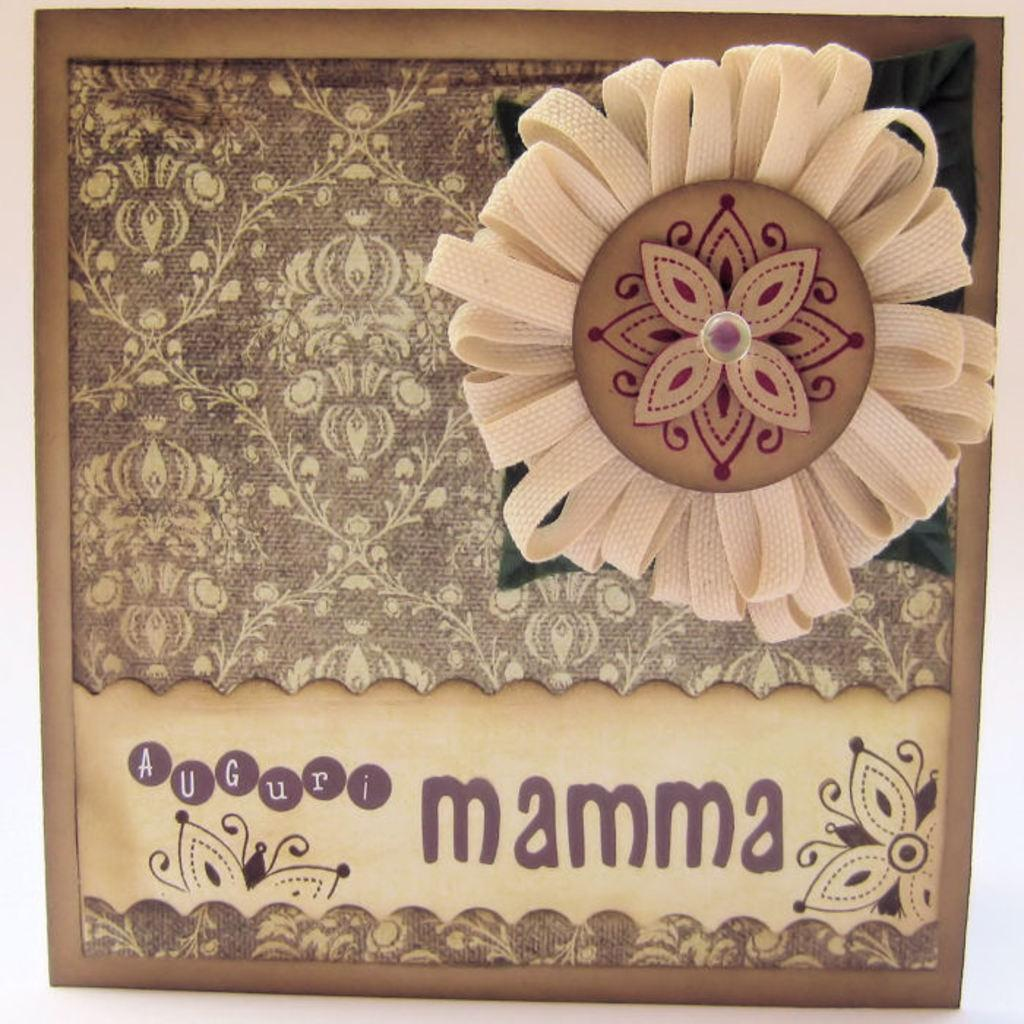What type of image is depicted in the motif? The image appears to be a motif, but we cannot determine the specific subject or theme from the provided facts. Is there any text associated with the motif? Yes, there is text at the bottom of the image. What can be seen on the right side of the motif? There is a cloth in the shape of a flower on the right side of the image. Can you describe the interaction between the stranger and the brother in the image? There is no stranger or brother present in the image; it features a motif with text and a cloth in the shape of a flower. 